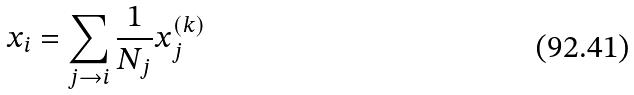Convert formula to latex. <formula><loc_0><loc_0><loc_500><loc_500>x _ { i } = \sum _ { j \rightarrow i } \frac { 1 } { N _ { j } } x _ { j } ^ { ( k ) }</formula> 